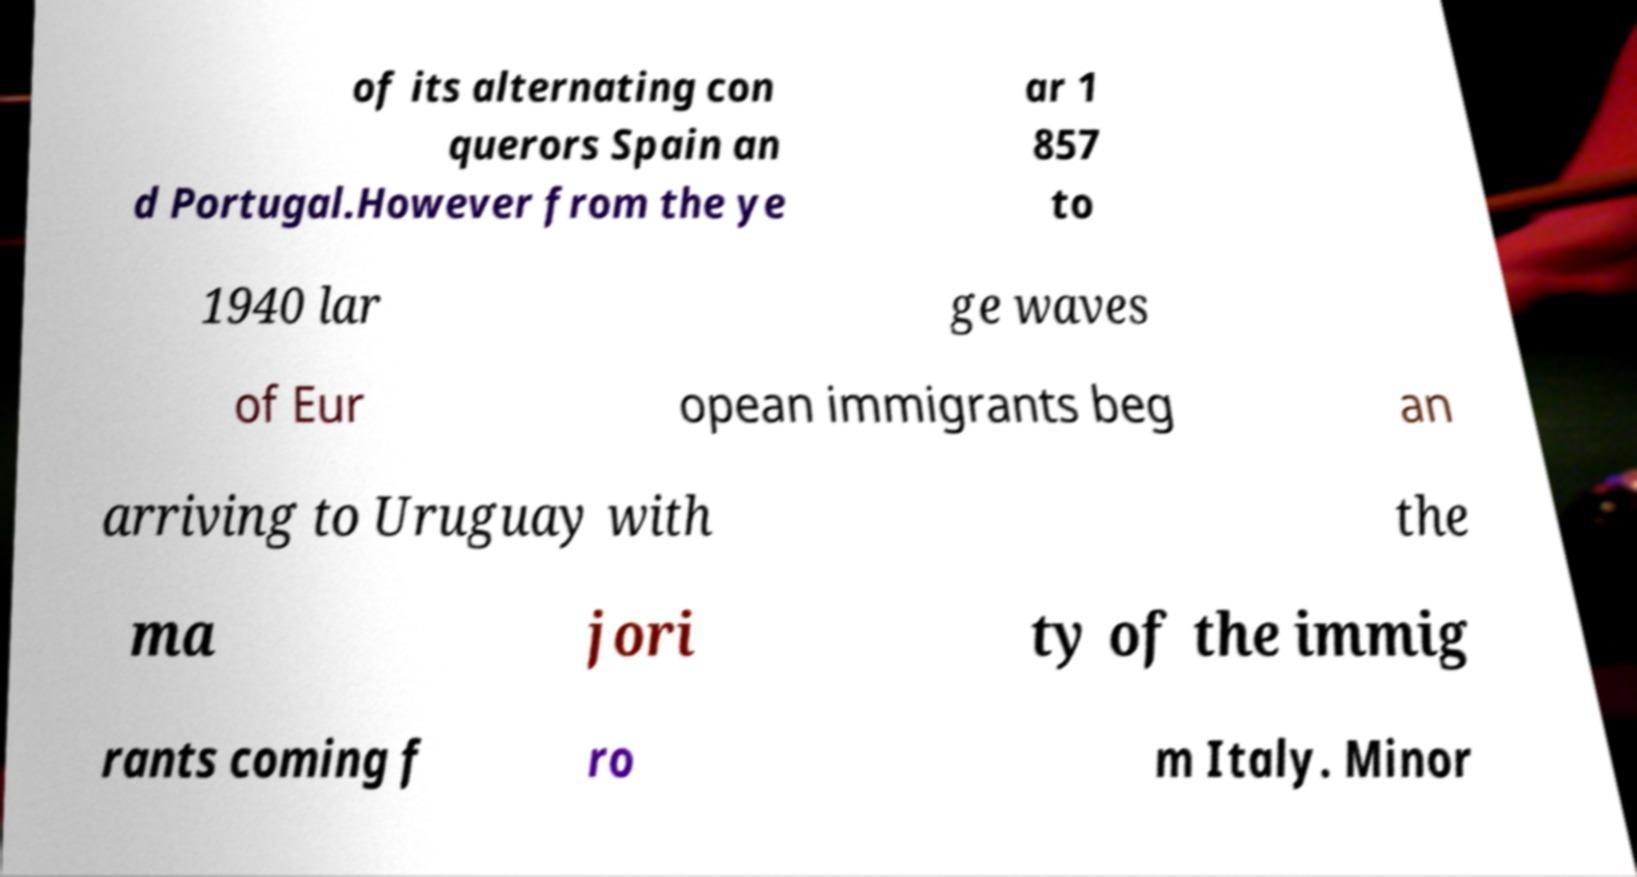Please read and relay the text visible in this image. What does it say? of its alternating con querors Spain an d Portugal.However from the ye ar 1 857 to 1940 lar ge waves of Eur opean immigrants beg an arriving to Uruguay with the ma jori ty of the immig rants coming f ro m Italy. Minor 